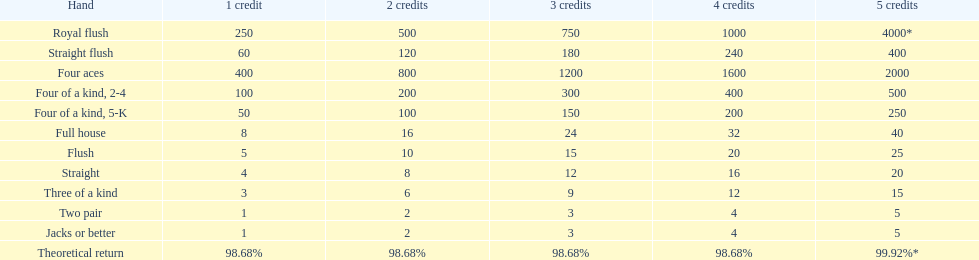Each quartet of aces triumph is a multiple of what numeral? 400. 